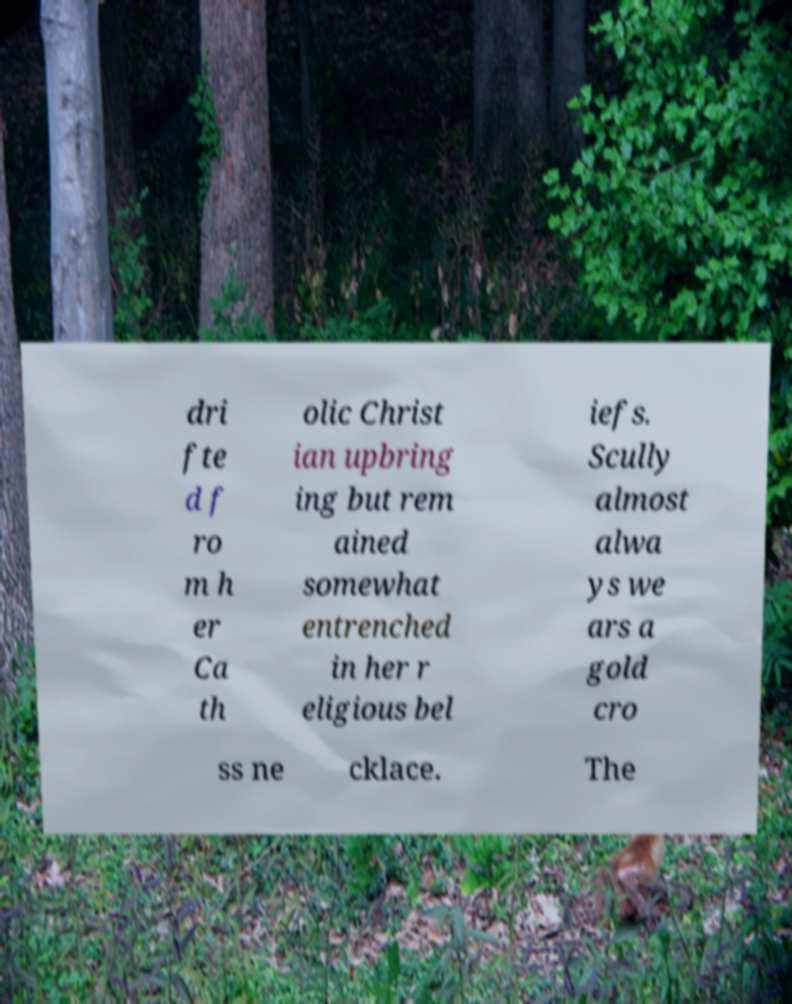There's text embedded in this image that I need extracted. Can you transcribe it verbatim? dri fte d f ro m h er Ca th olic Christ ian upbring ing but rem ained somewhat entrenched in her r eligious bel iefs. Scully almost alwa ys we ars a gold cro ss ne cklace. The 